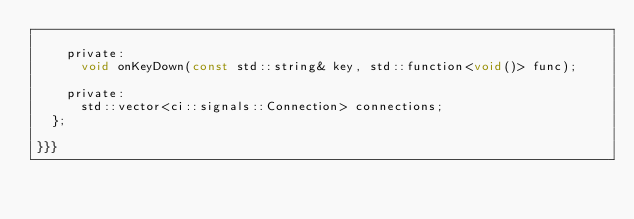Convert code to text. <code><loc_0><loc_0><loc_500><loc_500><_C_>
    private:
      void onKeyDown(const std::string& key, std::function<void()> func);

    private:
      std::vector<ci::signals::Connection> connections;
  };

}}}
</code> 